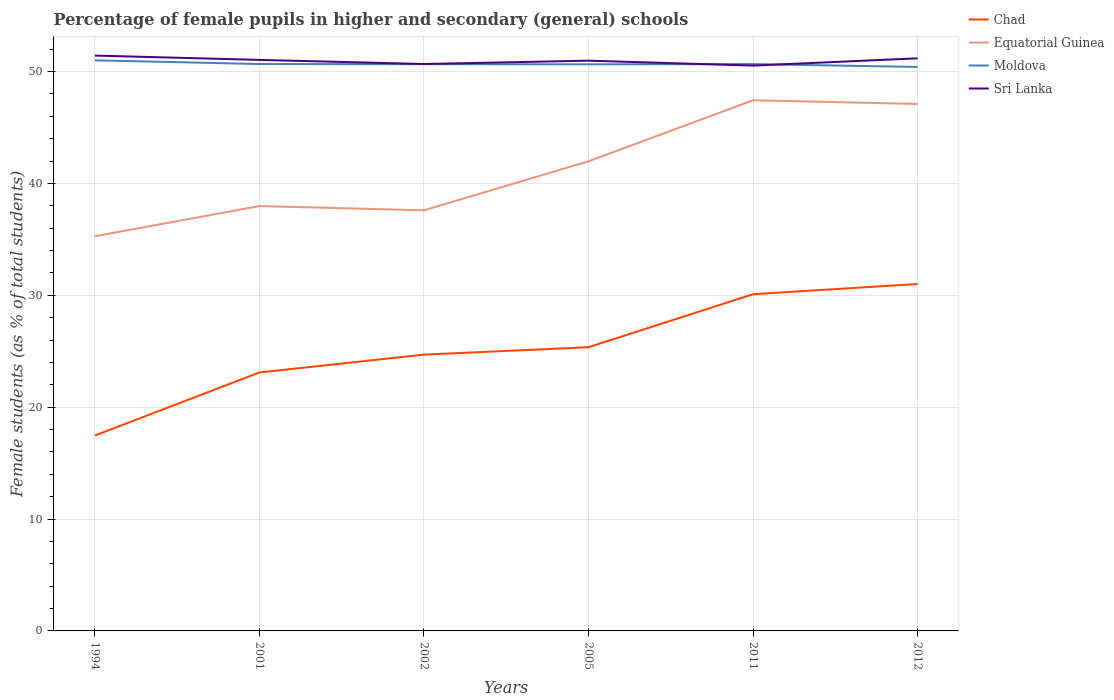How many different coloured lines are there?
Your answer should be compact. 4. Does the line corresponding to Chad intersect with the line corresponding to Sri Lanka?
Keep it short and to the point. No. Is the number of lines equal to the number of legend labels?
Your answer should be very brief. Yes. Across all years, what is the maximum percentage of female pupils in higher and secondary schools in Chad?
Make the answer very short. 17.46. In which year was the percentage of female pupils in higher and secondary schools in Chad maximum?
Offer a very short reply. 1994. What is the total percentage of female pupils in higher and secondary schools in Sri Lanka in the graph?
Your response must be concise. -0.21. What is the difference between the highest and the second highest percentage of female pupils in higher and secondary schools in Equatorial Guinea?
Your answer should be compact. 12.15. What is the difference between two consecutive major ticks on the Y-axis?
Ensure brevity in your answer.  10. Are the values on the major ticks of Y-axis written in scientific E-notation?
Ensure brevity in your answer.  No. How are the legend labels stacked?
Ensure brevity in your answer.  Vertical. What is the title of the graph?
Provide a succinct answer. Percentage of female pupils in higher and secondary (general) schools. What is the label or title of the X-axis?
Your answer should be very brief. Years. What is the label or title of the Y-axis?
Provide a short and direct response. Female students (as % of total students). What is the Female students (as % of total students) of Chad in 1994?
Give a very brief answer. 17.46. What is the Female students (as % of total students) of Equatorial Guinea in 1994?
Offer a very short reply. 35.28. What is the Female students (as % of total students) in Moldova in 1994?
Offer a very short reply. 51. What is the Female students (as % of total students) of Sri Lanka in 1994?
Give a very brief answer. 51.42. What is the Female students (as % of total students) in Chad in 2001?
Give a very brief answer. 23.1. What is the Female students (as % of total students) of Equatorial Guinea in 2001?
Offer a very short reply. 37.97. What is the Female students (as % of total students) of Moldova in 2001?
Make the answer very short. 50.67. What is the Female students (as % of total students) of Sri Lanka in 2001?
Offer a terse response. 51.04. What is the Female students (as % of total students) of Chad in 2002?
Your answer should be compact. 24.69. What is the Female students (as % of total students) of Equatorial Guinea in 2002?
Provide a short and direct response. 37.59. What is the Female students (as % of total students) of Moldova in 2002?
Offer a very short reply. 50.66. What is the Female students (as % of total students) of Sri Lanka in 2002?
Your answer should be very brief. 50.67. What is the Female students (as % of total students) in Chad in 2005?
Make the answer very short. 25.36. What is the Female students (as % of total students) in Equatorial Guinea in 2005?
Offer a very short reply. 41.98. What is the Female students (as % of total students) in Moldova in 2005?
Keep it short and to the point. 50.64. What is the Female students (as % of total students) in Sri Lanka in 2005?
Offer a very short reply. 50.97. What is the Female students (as % of total students) of Chad in 2011?
Offer a terse response. 30.1. What is the Female students (as % of total students) in Equatorial Guinea in 2011?
Make the answer very short. 47.43. What is the Female students (as % of total students) in Moldova in 2011?
Offer a very short reply. 50.67. What is the Female students (as % of total students) of Sri Lanka in 2011?
Your response must be concise. 50.53. What is the Female students (as % of total students) of Chad in 2012?
Your answer should be compact. 31.01. What is the Female students (as % of total students) of Equatorial Guinea in 2012?
Keep it short and to the point. 47.1. What is the Female students (as % of total students) in Moldova in 2012?
Give a very brief answer. 50.41. What is the Female students (as % of total students) of Sri Lanka in 2012?
Offer a very short reply. 51.18. Across all years, what is the maximum Female students (as % of total students) of Chad?
Offer a very short reply. 31.01. Across all years, what is the maximum Female students (as % of total students) in Equatorial Guinea?
Offer a terse response. 47.43. Across all years, what is the maximum Female students (as % of total students) in Moldova?
Your answer should be very brief. 51. Across all years, what is the maximum Female students (as % of total students) of Sri Lanka?
Provide a short and direct response. 51.42. Across all years, what is the minimum Female students (as % of total students) in Chad?
Offer a very short reply. 17.46. Across all years, what is the minimum Female students (as % of total students) of Equatorial Guinea?
Your response must be concise. 35.28. Across all years, what is the minimum Female students (as % of total students) in Moldova?
Ensure brevity in your answer.  50.41. Across all years, what is the minimum Female students (as % of total students) in Sri Lanka?
Your answer should be compact. 50.53. What is the total Female students (as % of total students) in Chad in the graph?
Provide a short and direct response. 151.72. What is the total Female students (as % of total students) in Equatorial Guinea in the graph?
Make the answer very short. 247.35. What is the total Female students (as % of total students) in Moldova in the graph?
Offer a very short reply. 304.04. What is the total Female students (as % of total students) of Sri Lanka in the graph?
Make the answer very short. 305.81. What is the difference between the Female students (as % of total students) in Chad in 1994 and that in 2001?
Give a very brief answer. -5.64. What is the difference between the Female students (as % of total students) in Equatorial Guinea in 1994 and that in 2001?
Offer a terse response. -2.7. What is the difference between the Female students (as % of total students) in Moldova in 1994 and that in 2001?
Provide a short and direct response. 0.33. What is the difference between the Female students (as % of total students) of Sri Lanka in 1994 and that in 2001?
Your response must be concise. 0.39. What is the difference between the Female students (as % of total students) of Chad in 1994 and that in 2002?
Make the answer very short. -7.23. What is the difference between the Female students (as % of total students) in Equatorial Guinea in 1994 and that in 2002?
Make the answer very short. -2.32. What is the difference between the Female students (as % of total students) in Moldova in 1994 and that in 2002?
Your answer should be very brief. 0.34. What is the difference between the Female students (as % of total students) of Sri Lanka in 1994 and that in 2002?
Offer a very short reply. 0.75. What is the difference between the Female students (as % of total students) in Chad in 1994 and that in 2005?
Keep it short and to the point. -7.89. What is the difference between the Female students (as % of total students) in Equatorial Guinea in 1994 and that in 2005?
Offer a terse response. -6.7. What is the difference between the Female students (as % of total students) in Moldova in 1994 and that in 2005?
Give a very brief answer. 0.36. What is the difference between the Female students (as % of total students) of Sri Lanka in 1994 and that in 2005?
Keep it short and to the point. 0.45. What is the difference between the Female students (as % of total students) in Chad in 1994 and that in 2011?
Make the answer very short. -12.63. What is the difference between the Female students (as % of total students) of Equatorial Guinea in 1994 and that in 2011?
Give a very brief answer. -12.15. What is the difference between the Female students (as % of total students) in Moldova in 1994 and that in 2011?
Offer a very short reply. 0.33. What is the difference between the Female students (as % of total students) in Sri Lanka in 1994 and that in 2011?
Ensure brevity in your answer.  0.9. What is the difference between the Female students (as % of total students) in Chad in 1994 and that in 2012?
Your response must be concise. -13.54. What is the difference between the Female students (as % of total students) in Equatorial Guinea in 1994 and that in 2012?
Offer a terse response. -11.82. What is the difference between the Female students (as % of total students) in Moldova in 1994 and that in 2012?
Ensure brevity in your answer.  0.59. What is the difference between the Female students (as % of total students) of Sri Lanka in 1994 and that in 2012?
Your response must be concise. 0.24. What is the difference between the Female students (as % of total students) of Chad in 2001 and that in 2002?
Ensure brevity in your answer.  -1.59. What is the difference between the Female students (as % of total students) in Equatorial Guinea in 2001 and that in 2002?
Make the answer very short. 0.38. What is the difference between the Female students (as % of total students) of Moldova in 2001 and that in 2002?
Offer a terse response. 0.01. What is the difference between the Female students (as % of total students) of Sri Lanka in 2001 and that in 2002?
Keep it short and to the point. 0.36. What is the difference between the Female students (as % of total students) of Chad in 2001 and that in 2005?
Offer a terse response. -2.26. What is the difference between the Female students (as % of total students) of Equatorial Guinea in 2001 and that in 2005?
Your answer should be compact. -4. What is the difference between the Female students (as % of total students) in Moldova in 2001 and that in 2005?
Ensure brevity in your answer.  0.03. What is the difference between the Female students (as % of total students) in Sri Lanka in 2001 and that in 2005?
Give a very brief answer. 0.07. What is the difference between the Female students (as % of total students) in Chad in 2001 and that in 2011?
Your answer should be very brief. -7. What is the difference between the Female students (as % of total students) in Equatorial Guinea in 2001 and that in 2011?
Your response must be concise. -9.45. What is the difference between the Female students (as % of total students) in Moldova in 2001 and that in 2011?
Give a very brief answer. 0. What is the difference between the Female students (as % of total students) in Sri Lanka in 2001 and that in 2011?
Ensure brevity in your answer.  0.51. What is the difference between the Female students (as % of total students) of Chad in 2001 and that in 2012?
Make the answer very short. -7.91. What is the difference between the Female students (as % of total students) of Equatorial Guinea in 2001 and that in 2012?
Keep it short and to the point. -9.13. What is the difference between the Female students (as % of total students) in Moldova in 2001 and that in 2012?
Provide a short and direct response. 0.26. What is the difference between the Female students (as % of total students) of Sri Lanka in 2001 and that in 2012?
Keep it short and to the point. -0.14. What is the difference between the Female students (as % of total students) in Chad in 2002 and that in 2005?
Provide a succinct answer. -0.66. What is the difference between the Female students (as % of total students) of Equatorial Guinea in 2002 and that in 2005?
Give a very brief answer. -4.38. What is the difference between the Female students (as % of total students) in Moldova in 2002 and that in 2005?
Provide a short and direct response. 0.02. What is the difference between the Female students (as % of total students) in Sri Lanka in 2002 and that in 2005?
Your answer should be compact. -0.3. What is the difference between the Female students (as % of total students) in Chad in 2002 and that in 2011?
Provide a short and direct response. -5.4. What is the difference between the Female students (as % of total students) of Equatorial Guinea in 2002 and that in 2011?
Your response must be concise. -9.83. What is the difference between the Female students (as % of total students) of Moldova in 2002 and that in 2011?
Keep it short and to the point. -0.01. What is the difference between the Female students (as % of total students) in Sri Lanka in 2002 and that in 2011?
Offer a terse response. 0.15. What is the difference between the Female students (as % of total students) in Chad in 2002 and that in 2012?
Provide a succinct answer. -6.31. What is the difference between the Female students (as % of total students) of Equatorial Guinea in 2002 and that in 2012?
Provide a succinct answer. -9.51. What is the difference between the Female students (as % of total students) of Moldova in 2002 and that in 2012?
Provide a succinct answer. 0.25. What is the difference between the Female students (as % of total students) in Sri Lanka in 2002 and that in 2012?
Your answer should be compact. -0.51. What is the difference between the Female students (as % of total students) in Chad in 2005 and that in 2011?
Your answer should be very brief. -4.74. What is the difference between the Female students (as % of total students) of Equatorial Guinea in 2005 and that in 2011?
Your response must be concise. -5.45. What is the difference between the Female students (as % of total students) of Moldova in 2005 and that in 2011?
Your answer should be compact. -0.03. What is the difference between the Female students (as % of total students) in Sri Lanka in 2005 and that in 2011?
Provide a succinct answer. 0.44. What is the difference between the Female students (as % of total students) of Chad in 2005 and that in 2012?
Make the answer very short. -5.65. What is the difference between the Female students (as % of total students) in Equatorial Guinea in 2005 and that in 2012?
Offer a very short reply. -5.13. What is the difference between the Female students (as % of total students) of Moldova in 2005 and that in 2012?
Offer a terse response. 0.23. What is the difference between the Female students (as % of total students) of Sri Lanka in 2005 and that in 2012?
Make the answer very short. -0.21. What is the difference between the Female students (as % of total students) in Chad in 2011 and that in 2012?
Provide a succinct answer. -0.91. What is the difference between the Female students (as % of total students) of Equatorial Guinea in 2011 and that in 2012?
Offer a terse response. 0.33. What is the difference between the Female students (as % of total students) in Moldova in 2011 and that in 2012?
Offer a very short reply. 0.26. What is the difference between the Female students (as % of total students) in Sri Lanka in 2011 and that in 2012?
Make the answer very short. -0.65. What is the difference between the Female students (as % of total students) of Chad in 1994 and the Female students (as % of total students) of Equatorial Guinea in 2001?
Your response must be concise. -20.51. What is the difference between the Female students (as % of total students) of Chad in 1994 and the Female students (as % of total students) of Moldova in 2001?
Provide a succinct answer. -33.21. What is the difference between the Female students (as % of total students) of Chad in 1994 and the Female students (as % of total students) of Sri Lanka in 2001?
Your response must be concise. -33.57. What is the difference between the Female students (as % of total students) in Equatorial Guinea in 1994 and the Female students (as % of total students) in Moldova in 2001?
Make the answer very short. -15.39. What is the difference between the Female students (as % of total students) of Equatorial Guinea in 1994 and the Female students (as % of total students) of Sri Lanka in 2001?
Offer a very short reply. -15.76. What is the difference between the Female students (as % of total students) in Moldova in 1994 and the Female students (as % of total students) in Sri Lanka in 2001?
Provide a succinct answer. -0.04. What is the difference between the Female students (as % of total students) of Chad in 1994 and the Female students (as % of total students) of Equatorial Guinea in 2002?
Ensure brevity in your answer.  -20.13. What is the difference between the Female students (as % of total students) of Chad in 1994 and the Female students (as % of total students) of Moldova in 2002?
Your response must be concise. -33.19. What is the difference between the Female students (as % of total students) in Chad in 1994 and the Female students (as % of total students) in Sri Lanka in 2002?
Your answer should be very brief. -33.21. What is the difference between the Female students (as % of total students) in Equatorial Guinea in 1994 and the Female students (as % of total students) in Moldova in 2002?
Give a very brief answer. -15.38. What is the difference between the Female students (as % of total students) in Equatorial Guinea in 1994 and the Female students (as % of total students) in Sri Lanka in 2002?
Give a very brief answer. -15.4. What is the difference between the Female students (as % of total students) in Moldova in 1994 and the Female students (as % of total students) in Sri Lanka in 2002?
Give a very brief answer. 0.33. What is the difference between the Female students (as % of total students) in Chad in 1994 and the Female students (as % of total students) in Equatorial Guinea in 2005?
Give a very brief answer. -24.51. What is the difference between the Female students (as % of total students) in Chad in 1994 and the Female students (as % of total students) in Moldova in 2005?
Give a very brief answer. -33.18. What is the difference between the Female students (as % of total students) in Chad in 1994 and the Female students (as % of total students) in Sri Lanka in 2005?
Make the answer very short. -33.51. What is the difference between the Female students (as % of total students) in Equatorial Guinea in 1994 and the Female students (as % of total students) in Moldova in 2005?
Give a very brief answer. -15.36. What is the difference between the Female students (as % of total students) in Equatorial Guinea in 1994 and the Female students (as % of total students) in Sri Lanka in 2005?
Provide a short and direct response. -15.69. What is the difference between the Female students (as % of total students) in Chad in 1994 and the Female students (as % of total students) in Equatorial Guinea in 2011?
Provide a succinct answer. -29.96. What is the difference between the Female students (as % of total students) of Chad in 1994 and the Female students (as % of total students) of Moldova in 2011?
Keep it short and to the point. -33.2. What is the difference between the Female students (as % of total students) of Chad in 1994 and the Female students (as % of total students) of Sri Lanka in 2011?
Keep it short and to the point. -33.06. What is the difference between the Female students (as % of total students) in Equatorial Guinea in 1994 and the Female students (as % of total students) in Moldova in 2011?
Your answer should be compact. -15.39. What is the difference between the Female students (as % of total students) in Equatorial Guinea in 1994 and the Female students (as % of total students) in Sri Lanka in 2011?
Offer a terse response. -15.25. What is the difference between the Female students (as % of total students) of Moldova in 1994 and the Female students (as % of total students) of Sri Lanka in 2011?
Make the answer very short. 0.47. What is the difference between the Female students (as % of total students) of Chad in 1994 and the Female students (as % of total students) of Equatorial Guinea in 2012?
Provide a succinct answer. -29.64. What is the difference between the Female students (as % of total students) of Chad in 1994 and the Female students (as % of total students) of Moldova in 2012?
Offer a terse response. -32.94. What is the difference between the Female students (as % of total students) of Chad in 1994 and the Female students (as % of total students) of Sri Lanka in 2012?
Your answer should be compact. -33.72. What is the difference between the Female students (as % of total students) of Equatorial Guinea in 1994 and the Female students (as % of total students) of Moldova in 2012?
Ensure brevity in your answer.  -15.13. What is the difference between the Female students (as % of total students) in Equatorial Guinea in 1994 and the Female students (as % of total students) in Sri Lanka in 2012?
Keep it short and to the point. -15.9. What is the difference between the Female students (as % of total students) in Moldova in 1994 and the Female students (as % of total students) in Sri Lanka in 2012?
Your answer should be very brief. -0.18. What is the difference between the Female students (as % of total students) of Chad in 2001 and the Female students (as % of total students) of Equatorial Guinea in 2002?
Your response must be concise. -14.49. What is the difference between the Female students (as % of total students) in Chad in 2001 and the Female students (as % of total students) in Moldova in 2002?
Your response must be concise. -27.56. What is the difference between the Female students (as % of total students) in Chad in 2001 and the Female students (as % of total students) in Sri Lanka in 2002?
Ensure brevity in your answer.  -27.57. What is the difference between the Female students (as % of total students) in Equatorial Guinea in 2001 and the Female students (as % of total students) in Moldova in 2002?
Offer a terse response. -12.68. What is the difference between the Female students (as % of total students) in Equatorial Guinea in 2001 and the Female students (as % of total students) in Sri Lanka in 2002?
Provide a succinct answer. -12.7. What is the difference between the Female students (as % of total students) in Moldova in 2001 and the Female students (as % of total students) in Sri Lanka in 2002?
Offer a terse response. -0. What is the difference between the Female students (as % of total students) of Chad in 2001 and the Female students (as % of total students) of Equatorial Guinea in 2005?
Provide a short and direct response. -18.88. What is the difference between the Female students (as % of total students) of Chad in 2001 and the Female students (as % of total students) of Moldova in 2005?
Make the answer very short. -27.54. What is the difference between the Female students (as % of total students) of Chad in 2001 and the Female students (as % of total students) of Sri Lanka in 2005?
Provide a short and direct response. -27.87. What is the difference between the Female students (as % of total students) in Equatorial Guinea in 2001 and the Female students (as % of total students) in Moldova in 2005?
Your answer should be compact. -12.67. What is the difference between the Female students (as % of total students) in Equatorial Guinea in 2001 and the Female students (as % of total students) in Sri Lanka in 2005?
Your response must be concise. -13. What is the difference between the Female students (as % of total students) of Moldova in 2001 and the Female students (as % of total students) of Sri Lanka in 2005?
Offer a terse response. -0.3. What is the difference between the Female students (as % of total students) in Chad in 2001 and the Female students (as % of total students) in Equatorial Guinea in 2011?
Your response must be concise. -24.33. What is the difference between the Female students (as % of total students) of Chad in 2001 and the Female students (as % of total students) of Moldova in 2011?
Offer a very short reply. -27.57. What is the difference between the Female students (as % of total students) in Chad in 2001 and the Female students (as % of total students) in Sri Lanka in 2011?
Keep it short and to the point. -27.43. What is the difference between the Female students (as % of total students) in Equatorial Guinea in 2001 and the Female students (as % of total students) in Moldova in 2011?
Keep it short and to the point. -12.69. What is the difference between the Female students (as % of total students) of Equatorial Guinea in 2001 and the Female students (as % of total students) of Sri Lanka in 2011?
Make the answer very short. -12.55. What is the difference between the Female students (as % of total students) of Moldova in 2001 and the Female students (as % of total students) of Sri Lanka in 2011?
Offer a very short reply. 0.14. What is the difference between the Female students (as % of total students) of Chad in 2001 and the Female students (as % of total students) of Equatorial Guinea in 2012?
Provide a short and direct response. -24. What is the difference between the Female students (as % of total students) in Chad in 2001 and the Female students (as % of total students) in Moldova in 2012?
Keep it short and to the point. -27.31. What is the difference between the Female students (as % of total students) of Chad in 2001 and the Female students (as % of total students) of Sri Lanka in 2012?
Make the answer very short. -28.08. What is the difference between the Female students (as % of total students) in Equatorial Guinea in 2001 and the Female students (as % of total students) in Moldova in 2012?
Your response must be concise. -12.43. What is the difference between the Female students (as % of total students) in Equatorial Guinea in 2001 and the Female students (as % of total students) in Sri Lanka in 2012?
Keep it short and to the point. -13.21. What is the difference between the Female students (as % of total students) in Moldova in 2001 and the Female students (as % of total students) in Sri Lanka in 2012?
Offer a very short reply. -0.51. What is the difference between the Female students (as % of total students) in Chad in 2002 and the Female students (as % of total students) in Equatorial Guinea in 2005?
Provide a succinct answer. -17.28. What is the difference between the Female students (as % of total students) of Chad in 2002 and the Female students (as % of total students) of Moldova in 2005?
Your answer should be very brief. -25.95. What is the difference between the Female students (as % of total students) of Chad in 2002 and the Female students (as % of total students) of Sri Lanka in 2005?
Offer a very short reply. -26.28. What is the difference between the Female students (as % of total students) of Equatorial Guinea in 2002 and the Female students (as % of total students) of Moldova in 2005?
Keep it short and to the point. -13.05. What is the difference between the Female students (as % of total students) in Equatorial Guinea in 2002 and the Female students (as % of total students) in Sri Lanka in 2005?
Provide a short and direct response. -13.38. What is the difference between the Female students (as % of total students) in Moldova in 2002 and the Female students (as % of total students) in Sri Lanka in 2005?
Your answer should be compact. -0.31. What is the difference between the Female students (as % of total students) of Chad in 2002 and the Female students (as % of total students) of Equatorial Guinea in 2011?
Provide a short and direct response. -22.73. What is the difference between the Female students (as % of total students) of Chad in 2002 and the Female students (as % of total students) of Moldova in 2011?
Keep it short and to the point. -25.97. What is the difference between the Female students (as % of total students) in Chad in 2002 and the Female students (as % of total students) in Sri Lanka in 2011?
Provide a short and direct response. -25.83. What is the difference between the Female students (as % of total students) of Equatorial Guinea in 2002 and the Female students (as % of total students) of Moldova in 2011?
Provide a short and direct response. -13.07. What is the difference between the Female students (as % of total students) of Equatorial Guinea in 2002 and the Female students (as % of total students) of Sri Lanka in 2011?
Offer a very short reply. -12.93. What is the difference between the Female students (as % of total students) in Moldova in 2002 and the Female students (as % of total students) in Sri Lanka in 2011?
Offer a very short reply. 0.13. What is the difference between the Female students (as % of total students) in Chad in 2002 and the Female students (as % of total students) in Equatorial Guinea in 2012?
Provide a short and direct response. -22.41. What is the difference between the Female students (as % of total students) of Chad in 2002 and the Female students (as % of total students) of Moldova in 2012?
Provide a succinct answer. -25.71. What is the difference between the Female students (as % of total students) in Chad in 2002 and the Female students (as % of total students) in Sri Lanka in 2012?
Provide a succinct answer. -26.49. What is the difference between the Female students (as % of total students) of Equatorial Guinea in 2002 and the Female students (as % of total students) of Moldova in 2012?
Offer a terse response. -12.81. What is the difference between the Female students (as % of total students) in Equatorial Guinea in 2002 and the Female students (as % of total students) in Sri Lanka in 2012?
Offer a very short reply. -13.59. What is the difference between the Female students (as % of total students) in Moldova in 2002 and the Female students (as % of total students) in Sri Lanka in 2012?
Your answer should be very brief. -0.52. What is the difference between the Female students (as % of total students) in Chad in 2005 and the Female students (as % of total students) in Equatorial Guinea in 2011?
Offer a terse response. -22.07. What is the difference between the Female students (as % of total students) of Chad in 2005 and the Female students (as % of total students) of Moldova in 2011?
Give a very brief answer. -25.31. What is the difference between the Female students (as % of total students) in Chad in 2005 and the Female students (as % of total students) in Sri Lanka in 2011?
Ensure brevity in your answer.  -25.17. What is the difference between the Female students (as % of total students) in Equatorial Guinea in 2005 and the Female students (as % of total students) in Moldova in 2011?
Your answer should be compact. -8.69. What is the difference between the Female students (as % of total students) in Equatorial Guinea in 2005 and the Female students (as % of total students) in Sri Lanka in 2011?
Your response must be concise. -8.55. What is the difference between the Female students (as % of total students) in Moldova in 2005 and the Female students (as % of total students) in Sri Lanka in 2011?
Offer a very short reply. 0.11. What is the difference between the Female students (as % of total students) of Chad in 2005 and the Female students (as % of total students) of Equatorial Guinea in 2012?
Your response must be concise. -21.74. What is the difference between the Female students (as % of total students) in Chad in 2005 and the Female students (as % of total students) in Moldova in 2012?
Your answer should be very brief. -25.05. What is the difference between the Female students (as % of total students) of Chad in 2005 and the Female students (as % of total students) of Sri Lanka in 2012?
Your answer should be very brief. -25.82. What is the difference between the Female students (as % of total students) of Equatorial Guinea in 2005 and the Female students (as % of total students) of Moldova in 2012?
Your response must be concise. -8.43. What is the difference between the Female students (as % of total students) in Equatorial Guinea in 2005 and the Female students (as % of total students) in Sri Lanka in 2012?
Your response must be concise. -9.2. What is the difference between the Female students (as % of total students) in Moldova in 2005 and the Female students (as % of total students) in Sri Lanka in 2012?
Keep it short and to the point. -0.54. What is the difference between the Female students (as % of total students) of Chad in 2011 and the Female students (as % of total students) of Equatorial Guinea in 2012?
Provide a succinct answer. -17. What is the difference between the Female students (as % of total students) in Chad in 2011 and the Female students (as % of total students) in Moldova in 2012?
Give a very brief answer. -20.31. What is the difference between the Female students (as % of total students) in Chad in 2011 and the Female students (as % of total students) in Sri Lanka in 2012?
Your answer should be very brief. -21.08. What is the difference between the Female students (as % of total students) of Equatorial Guinea in 2011 and the Female students (as % of total students) of Moldova in 2012?
Ensure brevity in your answer.  -2.98. What is the difference between the Female students (as % of total students) in Equatorial Guinea in 2011 and the Female students (as % of total students) in Sri Lanka in 2012?
Ensure brevity in your answer.  -3.75. What is the difference between the Female students (as % of total students) in Moldova in 2011 and the Female students (as % of total students) in Sri Lanka in 2012?
Offer a very short reply. -0.51. What is the average Female students (as % of total students) of Chad per year?
Give a very brief answer. 25.29. What is the average Female students (as % of total students) in Equatorial Guinea per year?
Make the answer very short. 41.22. What is the average Female students (as % of total students) in Moldova per year?
Offer a terse response. 50.67. What is the average Female students (as % of total students) in Sri Lanka per year?
Offer a very short reply. 50.97. In the year 1994, what is the difference between the Female students (as % of total students) of Chad and Female students (as % of total students) of Equatorial Guinea?
Provide a short and direct response. -17.81. In the year 1994, what is the difference between the Female students (as % of total students) in Chad and Female students (as % of total students) in Moldova?
Your answer should be very brief. -33.54. In the year 1994, what is the difference between the Female students (as % of total students) of Chad and Female students (as % of total students) of Sri Lanka?
Keep it short and to the point. -33.96. In the year 1994, what is the difference between the Female students (as % of total students) in Equatorial Guinea and Female students (as % of total students) in Moldova?
Give a very brief answer. -15.72. In the year 1994, what is the difference between the Female students (as % of total students) of Equatorial Guinea and Female students (as % of total students) of Sri Lanka?
Give a very brief answer. -16.15. In the year 1994, what is the difference between the Female students (as % of total students) of Moldova and Female students (as % of total students) of Sri Lanka?
Ensure brevity in your answer.  -0.42. In the year 2001, what is the difference between the Female students (as % of total students) of Chad and Female students (as % of total students) of Equatorial Guinea?
Make the answer very short. -14.87. In the year 2001, what is the difference between the Female students (as % of total students) of Chad and Female students (as % of total students) of Moldova?
Provide a succinct answer. -27.57. In the year 2001, what is the difference between the Female students (as % of total students) of Chad and Female students (as % of total students) of Sri Lanka?
Provide a short and direct response. -27.94. In the year 2001, what is the difference between the Female students (as % of total students) in Equatorial Guinea and Female students (as % of total students) in Moldova?
Provide a succinct answer. -12.7. In the year 2001, what is the difference between the Female students (as % of total students) in Equatorial Guinea and Female students (as % of total students) in Sri Lanka?
Give a very brief answer. -13.06. In the year 2001, what is the difference between the Female students (as % of total students) of Moldova and Female students (as % of total students) of Sri Lanka?
Your answer should be very brief. -0.37. In the year 2002, what is the difference between the Female students (as % of total students) of Chad and Female students (as % of total students) of Equatorial Guinea?
Provide a succinct answer. -12.9. In the year 2002, what is the difference between the Female students (as % of total students) of Chad and Female students (as % of total students) of Moldova?
Your answer should be compact. -25.96. In the year 2002, what is the difference between the Female students (as % of total students) of Chad and Female students (as % of total students) of Sri Lanka?
Your answer should be compact. -25.98. In the year 2002, what is the difference between the Female students (as % of total students) of Equatorial Guinea and Female students (as % of total students) of Moldova?
Offer a terse response. -13.06. In the year 2002, what is the difference between the Female students (as % of total students) in Equatorial Guinea and Female students (as % of total students) in Sri Lanka?
Offer a very short reply. -13.08. In the year 2002, what is the difference between the Female students (as % of total students) of Moldova and Female students (as % of total students) of Sri Lanka?
Your answer should be very brief. -0.02. In the year 2005, what is the difference between the Female students (as % of total students) in Chad and Female students (as % of total students) in Equatorial Guinea?
Offer a very short reply. -16.62. In the year 2005, what is the difference between the Female students (as % of total students) of Chad and Female students (as % of total students) of Moldova?
Offer a very short reply. -25.28. In the year 2005, what is the difference between the Female students (as % of total students) of Chad and Female students (as % of total students) of Sri Lanka?
Keep it short and to the point. -25.61. In the year 2005, what is the difference between the Female students (as % of total students) of Equatorial Guinea and Female students (as % of total students) of Moldova?
Offer a very short reply. -8.67. In the year 2005, what is the difference between the Female students (as % of total students) in Equatorial Guinea and Female students (as % of total students) in Sri Lanka?
Your answer should be compact. -8.99. In the year 2005, what is the difference between the Female students (as % of total students) in Moldova and Female students (as % of total students) in Sri Lanka?
Offer a terse response. -0.33. In the year 2011, what is the difference between the Female students (as % of total students) of Chad and Female students (as % of total students) of Equatorial Guinea?
Make the answer very short. -17.33. In the year 2011, what is the difference between the Female students (as % of total students) of Chad and Female students (as % of total students) of Moldova?
Make the answer very short. -20.57. In the year 2011, what is the difference between the Female students (as % of total students) of Chad and Female students (as % of total students) of Sri Lanka?
Provide a short and direct response. -20.43. In the year 2011, what is the difference between the Female students (as % of total students) of Equatorial Guinea and Female students (as % of total students) of Moldova?
Ensure brevity in your answer.  -3.24. In the year 2011, what is the difference between the Female students (as % of total students) in Equatorial Guinea and Female students (as % of total students) in Sri Lanka?
Your response must be concise. -3.1. In the year 2011, what is the difference between the Female students (as % of total students) in Moldova and Female students (as % of total students) in Sri Lanka?
Offer a terse response. 0.14. In the year 2012, what is the difference between the Female students (as % of total students) in Chad and Female students (as % of total students) in Equatorial Guinea?
Offer a terse response. -16.09. In the year 2012, what is the difference between the Female students (as % of total students) of Chad and Female students (as % of total students) of Moldova?
Ensure brevity in your answer.  -19.4. In the year 2012, what is the difference between the Female students (as % of total students) of Chad and Female students (as % of total students) of Sri Lanka?
Provide a succinct answer. -20.17. In the year 2012, what is the difference between the Female students (as % of total students) in Equatorial Guinea and Female students (as % of total students) in Moldova?
Provide a short and direct response. -3.31. In the year 2012, what is the difference between the Female students (as % of total students) in Equatorial Guinea and Female students (as % of total students) in Sri Lanka?
Keep it short and to the point. -4.08. In the year 2012, what is the difference between the Female students (as % of total students) of Moldova and Female students (as % of total students) of Sri Lanka?
Make the answer very short. -0.77. What is the ratio of the Female students (as % of total students) of Chad in 1994 to that in 2001?
Make the answer very short. 0.76. What is the ratio of the Female students (as % of total students) of Equatorial Guinea in 1994 to that in 2001?
Give a very brief answer. 0.93. What is the ratio of the Female students (as % of total students) in Moldova in 1994 to that in 2001?
Offer a terse response. 1.01. What is the ratio of the Female students (as % of total students) of Sri Lanka in 1994 to that in 2001?
Your response must be concise. 1.01. What is the ratio of the Female students (as % of total students) of Chad in 1994 to that in 2002?
Give a very brief answer. 0.71. What is the ratio of the Female students (as % of total students) in Equatorial Guinea in 1994 to that in 2002?
Provide a succinct answer. 0.94. What is the ratio of the Female students (as % of total students) of Moldova in 1994 to that in 2002?
Keep it short and to the point. 1.01. What is the ratio of the Female students (as % of total students) of Sri Lanka in 1994 to that in 2002?
Provide a succinct answer. 1.01. What is the ratio of the Female students (as % of total students) of Chad in 1994 to that in 2005?
Make the answer very short. 0.69. What is the ratio of the Female students (as % of total students) in Equatorial Guinea in 1994 to that in 2005?
Make the answer very short. 0.84. What is the ratio of the Female students (as % of total students) in Moldova in 1994 to that in 2005?
Keep it short and to the point. 1.01. What is the ratio of the Female students (as % of total students) of Sri Lanka in 1994 to that in 2005?
Provide a short and direct response. 1.01. What is the ratio of the Female students (as % of total students) of Chad in 1994 to that in 2011?
Offer a very short reply. 0.58. What is the ratio of the Female students (as % of total students) of Equatorial Guinea in 1994 to that in 2011?
Offer a terse response. 0.74. What is the ratio of the Female students (as % of total students) of Moldova in 1994 to that in 2011?
Your answer should be compact. 1.01. What is the ratio of the Female students (as % of total students) in Sri Lanka in 1994 to that in 2011?
Offer a very short reply. 1.02. What is the ratio of the Female students (as % of total students) of Chad in 1994 to that in 2012?
Give a very brief answer. 0.56. What is the ratio of the Female students (as % of total students) of Equatorial Guinea in 1994 to that in 2012?
Make the answer very short. 0.75. What is the ratio of the Female students (as % of total students) in Moldova in 1994 to that in 2012?
Provide a succinct answer. 1.01. What is the ratio of the Female students (as % of total students) in Chad in 2001 to that in 2002?
Keep it short and to the point. 0.94. What is the ratio of the Female students (as % of total students) of Equatorial Guinea in 2001 to that in 2002?
Provide a short and direct response. 1.01. What is the ratio of the Female students (as % of total students) of Chad in 2001 to that in 2005?
Provide a short and direct response. 0.91. What is the ratio of the Female students (as % of total students) in Equatorial Guinea in 2001 to that in 2005?
Ensure brevity in your answer.  0.9. What is the ratio of the Female students (as % of total students) of Sri Lanka in 2001 to that in 2005?
Your answer should be compact. 1. What is the ratio of the Female students (as % of total students) in Chad in 2001 to that in 2011?
Offer a terse response. 0.77. What is the ratio of the Female students (as % of total students) of Equatorial Guinea in 2001 to that in 2011?
Provide a succinct answer. 0.8. What is the ratio of the Female students (as % of total students) in Sri Lanka in 2001 to that in 2011?
Ensure brevity in your answer.  1.01. What is the ratio of the Female students (as % of total students) of Chad in 2001 to that in 2012?
Your answer should be compact. 0.74. What is the ratio of the Female students (as % of total students) of Equatorial Guinea in 2001 to that in 2012?
Offer a very short reply. 0.81. What is the ratio of the Female students (as % of total students) in Moldova in 2001 to that in 2012?
Give a very brief answer. 1.01. What is the ratio of the Female students (as % of total students) of Chad in 2002 to that in 2005?
Your response must be concise. 0.97. What is the ratio of the Female students (as % of total students) of Equatorial Guinea in 2002 to that in 2005?
Offer a very short reply. 0.9. What is the ratio of the Female students (as % of total students) of Moldova in 2002 to that in 2005?
Your answer should be very brief. 1. What is the ratio of the Female students (as % of total students) in Chad in 2002 to that in 2011?
Offer a very short reply. 0.82. What is the ratio of the Female students (as % of total students) in Equatorial Guinea in 2002 to that in 2011?
Offer a very short reply. 0.79. What is the ratio of the Female students (as % of total students) in Chad in 2002 to that in 2012?
Offer a terse response. 0.8. What is the ratio of the Female students (as % of total students) of Equatorial Guinea in 2002 to that in 2012?
Make the answer very short. 0.8. What is the ratio of the Female students (as % of total students) in Sri Lanka in 2002 to that in 2012?
Ensure brevity in your answer.  0.99. What is the ratio of the Female students (as % of total students) in Chad in 2005 to that in 2011?
Your response must be concise. 0.84. What is the ratio of the Female students (as % of total students) in Equatorial Guinea in 2005 to that in 2011?
Give a very brief answer. 0.89. What is the ratio of the Female students (as % of total students) of Moldova in 2005 to that in 2011?
Your answer should be very brief. 1. What is the ratio of the Female students (as % of total students) of Sri Lanka in 2005 to that in 2011?
Offer a terse response. 1.01. What is the ratio of the Female students (as % of total students) in Chad in 2005 to that in 2012?
Ensure brevity in your answer.  0.82. What is the ratio of the Female students (as % of total students) in Equatorial Guinea in 2005 to that in 2012?
Ensure brevity in your answer.  0.89. What is the ratio of the Female students (as % of total students) of Sri Lanka in 2005 to that in 2012?
Offer a very short reply. 1. What is the ratio of the Female students (as % of total students) of Chad in 2011 to that in 2012?
Give a very brief answer. 0.97. What is the ratio of the Female students (as % of total students) of Equatorial Guinea in 2011 to that in 2012?
Ensure brevity in your answer.  1.01. What is the ratio of the Female students (as % of total students) in Sri Lanka in 2011 to that in 2012?
Offer a terse response. 0.99. What is the difference between the highest and the second highest Female students (as % of total students) of Chad?
Keep it short and to the point. 0.91. What is the difference between the highest and the second highest Female students (as % of total students) of Equatorial Guinea?
Provide a short and direct response. 0.33. What is the difference between the highest and the second highest Female students (as % of total students) in Moldova?
Make the answer very short. 0.33. What is the difference between the highest and the second highest Female students (as % of total students) of Sri Lanka?
Make the answer very short. 0.24. What is the difference between the highest and the lowest Female students (as % of total students) in Chad?
Give a very brief answer. 13.54. What is the difference between the highest and the lowest Female students (as % of total students) in Equatorial Guinea?
Offer a very short reply. 12.15. What is the difference between the highest and the lowest Female students (as % of total students) of Moldova?
Your answer should be very brief. 0.59. What is the difference between the highest and the lowest Female students (as % of total students) of Sri Lanka?
Offer a terse response. 0.9. 